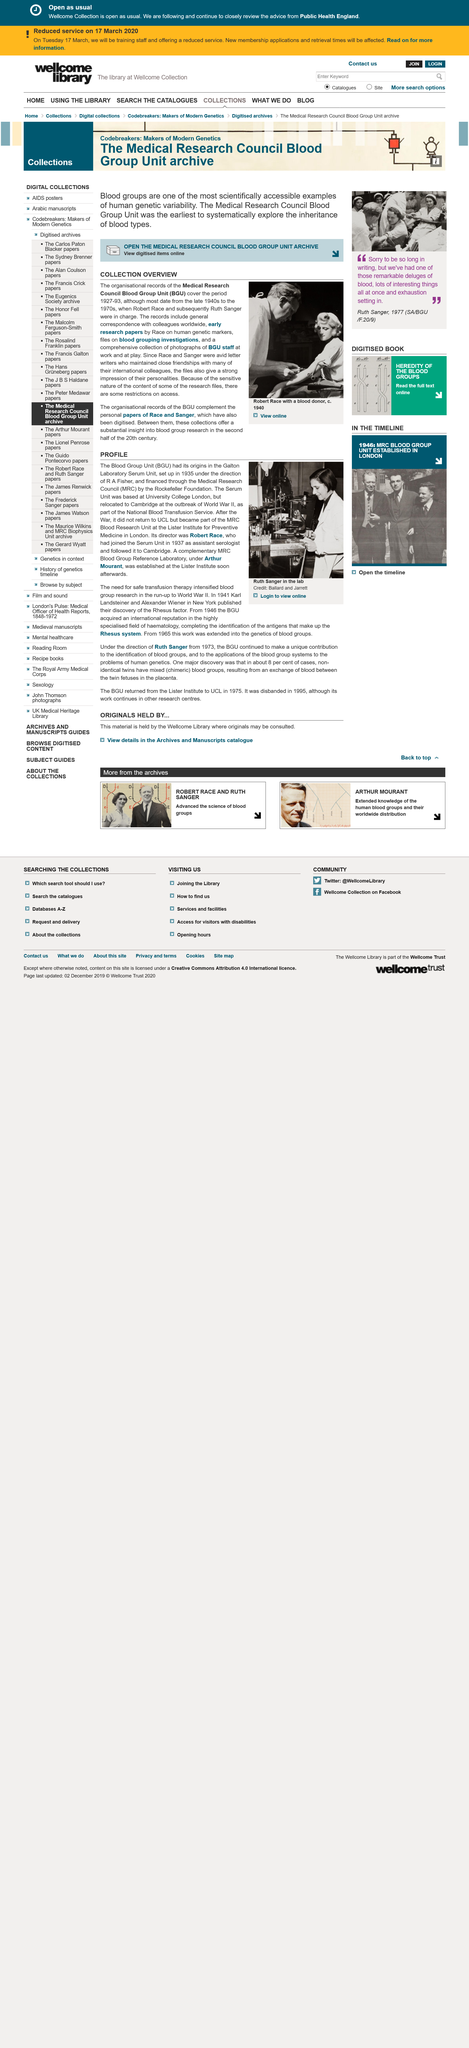Mention a couple of crucial points in this snapshot. The relationship between Race and Sanger was close and personal, as they were friends. In 1935, the Blood Group Unit was established. The organisational records of the Medical Research Council Blood Group Unit cover the period from 1927 to 1993. Robert Race joined the Serum unit in 1937. Access to the Medical Research Council Blood Group Unit is restricted due to the sensitive nature of some of its content. 